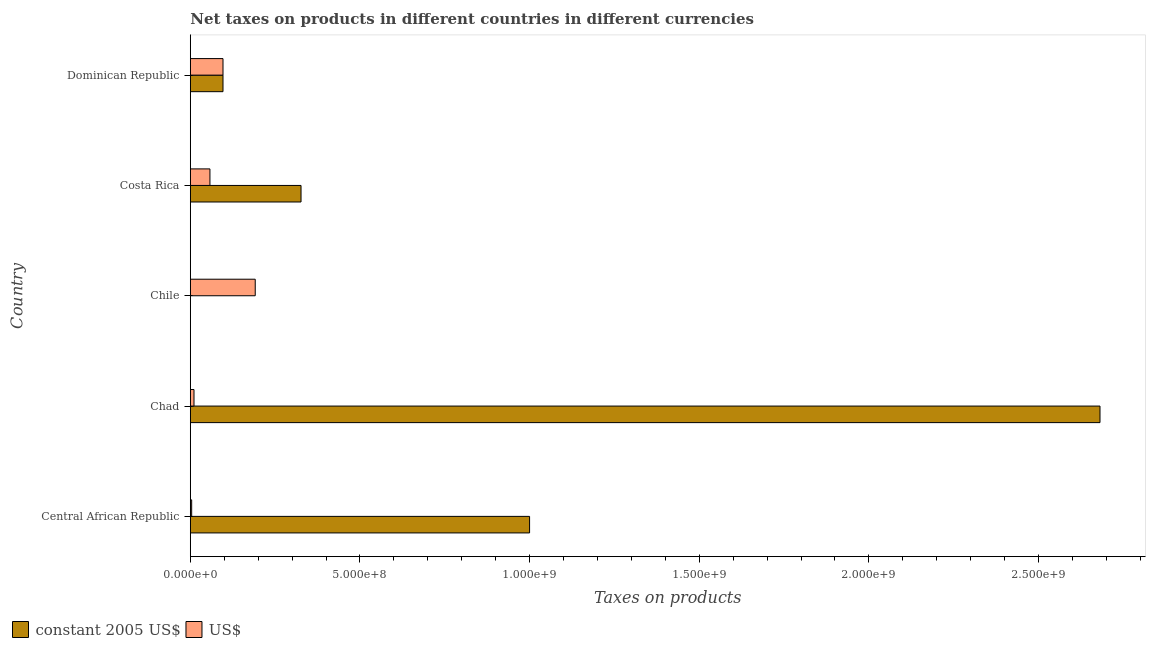How many different coloured bars are there?
Your answer should be compact. 2. Are the number of bars on each tick of the Y-axis equal?
Ensure brevity in your answer.  Yes. How many bars are there on the 3rd tick from the top?
Ensure brevity in your answer.  2. What is the label of the 5th group of bars from the top?
Provide a succinct answer. Central African Republic. What is the net taxes in constant 2005 us$ in Dominican Republic?
Your answer should be compact. 9.64e+07. Across all countries, what is the maximum net taxes in constant 2005 us$?
Keep it short and to the point. 2.68e+09. Across all countries, what is the minimum net taxes in constant 2005 us$?
Give a very brief answer. 2.02e+05. In which country was the net taxes in us$ minimum?
Provide a succinct answer. Central African Republic. What is the total net taxes in us$ in the graph?
Provide a short and direct response. 3.61e+08. What is the difference between the net taxes in constant 2005 us$ in Chad and that in Dominican Republic?
Your answer should be compact. 2.58e+09. What is the difference between the net taxes in constant 2005 us$ in Dominican Republic and the net taxes in us$ in Chad?
Provide a succinct answer. 8.55e+07. What is the average net taxes in constant 2005 us$ per country?
Your response must be concise. 8.21e+08. What is the difference between the net taxes in constant 2005 us$ and net taxes in us$ in Chile?
Ensure brevity in your answer.  -1.91e+08. In how many countries, is the net taxes in constant 2005 us$ greater than 1200000000 units?
Provide a succinct answer. 1. Is the net taxes in constant 2005 us$ in Costa Rica less than that in Dominican Republic?
Ensure brevity in your answer.  No. Is the difference between the net taxes in us$ in Chad and Chile greater than the difference between the net taxes in constant 2005 us$ in Chad and Chile?
Your response must be concise. No. What is the difference between the highest and the second highest net taxes in us$?
Keep it short and to the point. 9.50e+07. What is the difference between the highest and the lowest net taxes in us$?
Provide a short and direct response. 1.87e+08. Is the sum of the net taxes in constant 2005 us$ in Costa Rica and Dominican Republic greater than the maximum net taxes in us$ across all countries?
Provide a succinct answer. Yes. What does the 1st bar from the top in Chad represents?
Your answer should be compact. US$. What does the 1st bar from the bottom in Dominican Republic represents?
Offer a very short reply. Constant 2005 us$. How many bars are there?
Keep it short and to the point. 10. Are all the bars in the graph horizontal?
Provide a succinct answer. Yes. How many countries are there in the graph?
Give a very brief answer. 5. Does the graph contain any zero values?
Keep it short and to the point. No. What is the title of the graph?
Give a very brief answer. Net taxes on products in different countries in different currencies. Does "Sanitation services" appear as one of the legend labels in the graph?
Your answer should be very brief. No. What is the label or title of the X-axis?
Offer a terse response. Taxes on products. What is the Taxes on products in constant 2005 US$ in Central African Republic?
Provide a succinct answer. 1.00e+09. What is the Taxes on products in US$ in Central African Republic?
Make the answer very short. 4.08e+06. What is the Taxes on products of constant 2005 US$ in Chad?
Provide a succinct answer. 2.68e+09. What is the Taxes on products of US$ in Chad?
Ensure brevity in your answer.  1.09e+07. What is the Taxes on products in constant 2005 US$ in Chile?
Keep it short and to the point. 2.02e+05. What is the Taxes on products in US$ in Chile?
Your response must be concise. 1.91e+08. What is the Taxes on products of constant 2005 US$ in Costa Rica?
Keep it short and to the point. 3.26e+08. What is the Taxes on products in US$ in Costa Rica?
Your answer should be compact. 5.79e+07. What is the Taxes on products of constant 2005 US$ in Dominican Republic?
Keep it short and to the point. 9.64e+07. What is the Taxes on products in US$ in Dominican Republic?
Provide a short and direct response. 9.64e+07. Across all countries, what is the maximum Taxes on products in constant 2005 US$?
Make the answer very short. 2.68e+09. Across all countries, what is the maximum Taxes on products of US$?
Your answer should be very brief. 1.91e+08. Across all countries, what is the minimum Taxes on products in constant 2005 US$?
Provide a succinct answer. 2.02e+05. Across all countries, what is the minimum Taxes on products in US$?
Keep it short and to the point. 4.08e+06. What is the total Taxes on products of constant 2005 US$ in the graph?
Ensure brevity in your answer.  4.10e+09. What is the total Taxes on products in US$ in the graph?
Offer a very short reply. 3.61e+08. What is the difference between the Taxes on products in constant 2005 US$ in Central African Republic and that in Chad?
Offer a very short reply. -1.68e+09. What is the difference between the Taxes on products of US$ in Central African Republic and that in Chad?
Keep it short and to the point. -6.86e+06. What is the difference between the Taxes on products of constant 2005 US$ in Central African Republic and that in Chile?
Your answer should be compact. 1.00e+09. What is the difference between the Taxes on products in US$ in Central African Republic and that in Chile?
Ensure brevity in your answer.  -1.87e+08. What is the difference between the Taxes on products of constant 2005 US$ in Central African Republic and that in Costa Rica?
Your answer should be compact. 6.74e+08. What is the difference between the Taxes on products of US$ in Central African Republic and that in Costa Rica?
Make the answer very short. -5.38e+07. What is the difference between the Taxes on products of constant 2005 US$ in Central African Republic and that in Dominican Republic?
Make the answer very short. 9.04e+08. What is the difference between the Taxes on products in US$ in Central African Republic and that in Dominican Republic?
Provide a succinct answer. -9.23e+07. What is the difference between the Taxes on products of constant 2005 US$ in Chad and that in Chile?
Provide a succinct answer. 2.68e+09. What is the difference between the Taxes on products in US$ in Chad and that in Chile?
Make the answer very short. -1.80e+08. What is the difference between the Taxes on products in constant 2005 US$ in Chad and that in Costa Rica?
Provide a short and direct response. 2.35e+09. What is the difference between the Taxes on products in US$ in Chad and that in Costa Rica?
Provide a succinct answer. -4.70e+07. What is the difference between the Taxes on products in constant 2005 US$ in Chad and that in Dominican Republic?
Your response must be concise. 2.58e+09. What is the difference between the Taxes on products of US$ in Chad and that in Dominican Republic?
Provide a short and direct response. -8.55e+07. What is the difference between the Taxes on products of constant 2005 US$ in Chile and that in Costa Rica?
Provide a succinct answer. -3.26e+08. What is the difference between the Taxes on products of US$ in Chile and that in Costa Rica?
Provide a short and direct response. 1.33e+08. What is the difference between the Taxes on products of constant 2005 US$ in Chile and that in Dominican Republic?
Offer a terse response. -9.62e+07. What is the difference between the Taxes on products in US$ in Chile and that in Dominican Republic?
Your answer should be compact. 9.50e+07. What is the difference between the Taxes on products in constant 2005 US$ in Costa Rica and that in Dominican Republic?
Your answer should be very brief. 2.30e+08. What is the difference between the Taxes on products of US$ in Costa Rica and that in Dominican Republic?
Give a very brief answer. -3.85e+07. What is the difference between the Taxes on products of constant 2005 US$ in Central African Republic and the Taxes on products of US$ in Chad?
Provide a short and direct response. 9.89e+08. What is the difference between the Taxes on products in constant 2005 US$ in Central African Republic and the Taxes on products in US$ in Chile?
Ensure brevity in your answer.  8.09e+08. What is the difference between the Taxes on products of constant 2005 US$ in Central African Republic and the Taxes on products of US$ in Costa Rica?
Give a very brief answer. 9.42e+08. What is the difference between the Taxes on products in constant 2005 US$ in Central African Republic and the Taxes on products in US$ in Dominican Republic?
Give a very brief answer. 9.04e+08. What is the difference between the Taxes on products of constant 2005 US$ in Chad and the Taxes on products of US$ in Chile?
Ensure brevity in your answer.  2.49e+09. What is the difference between the Taxes on products in constant 2005 US$ in Chad and the Taxes on products in US$ in Costa Rica?
Provide a short and direct response. 2.62e+09. What is the difference between the Taxes on products in constant 2005 US$ in Chad and the Taxes on products in US$ in Dominican Republic?
Provide a short and direct response. 2.58e+09. What is the difference between the Taxes on products of constant 2005 US$ in Chile and the Taxes on products of US$ in Costa Rica?
Provide a succinct answer. -5.77e+07. What is the difference between the Taxes on products in constant 2005 US$ in Chile and the Taxes on products in US$ in Dominican Republic?
Your answer should be compact. -9.62e+07. What is the difference between the Taxes on products in constant 2005 US$ in Costa Rica and the Taxes on products in US$ in Dominican Republic?
Your answer should be very brief. 2.30e+08. What is the average Taxes on products in constant 2005 US$ per country?
Keep it short and to the point. 8.21e+08. What is the average Taxes on products in US$ per country?
Your response must be concise. 7.21e+07. What is the difference between the Taxes on products in constant 2005 US$ and Taxes on products in US$ in Central African Republic?
Make the answer very short. 9.96e+08. What is the difference between the Taxes on products of constant 2005 US$ and Taxes on products of US$ in Chad?
Make the answer very short. 2.67e+09. What is the difference between the Taxes on products in constant 2005 US$ and Taxes on products in US$ in Chile?
Offer a very short reply. -1.91e+08. What is the difference between the Taxes on products in constant 2005 US$ and Taxes on products in US$ in Costa Rica?
Your answer should be compact. 2.68e+08. What is the difference between the Taxes on products in constant 2005 US$ and Taxes on products in US$ in Dominican Republic?
Keep it short and to the point. 0. What is the ratio of the Taxes on products of constant 2005 US$ in Central African Republic to that in Chad?
Offer a very short reply. 0.37. What is the ratio of the Taxes on products of US$ in Central African Republic to that in Chad?
Your answer should be compact. 0.37. What is the ratio of the Taxes on products in constant 2005 US$ in Central African Republic to that in Chile?
Make the answer very short. 4938.27. What is the ratio of the Taxes on products of US$ in Central African Republic to that in Chile?
Your answer should be very brief. 0.02. What is the ratio of the Taxes on products of constant 2005 US$ in Central African Republic to that in Costa Rica?
Ensure brevity in your answer.  3.06. What is the ratio of the Taxes on products of US$ in Central African Republic to that in Costa Rica?
Provide a short and direct response. 0.07. What is the ratio of the Taxes on products in constant 2005 US$ in Central African Republic to that in Dominican Republic?
Provide a succinct answer. 10.37. What is the ratio of the Taxes on products of US$ in Central African Republic to that in Dominican Republic?
Your answer should be compact. 0.04. What is the ratio of the Taxes on products of constant 2005 US$ in Chad to that in Chile?
Offer a very short reply. 1.32e+04. What is the ratio of the Taxes on products in US$ in Chad to that in Chile?
Offer a terse response. 0.06. What is the ratio of the Taxes on products of constant 2005 US$ in Chad to that in Costa Rica?
Your response must be concise. 8.21. What is the ratio of the Taxes on products in US$ in Chad to that in Costa Rica?
Offer a very short reply. 0.19. What is the ratio of the Taxes on products of constant 2005 US$ in Chad to that in Dominican Republic?
Ensure brevity in your answer.  27.81. What is the ratio of the Taxes on products in US$ in Chad to that in Dominican Republic?
Ensure brevity in your answer.  0.11. What is the ratio of the Taxes on products of constant 2005 US$ in Chile to that in Costa Rica?
Ensure brevity in your answer.  0. What is the ratio of the Taxes on products of US$ in Chile to that in Costa Rica?
Offer a very short reply. 3.31. What is the ratio of the Taxes on products of constant 2005 US$ in Chile to that in Dominican Republic?
Your answer should be very brief. 0. What is the ratio of the Taxes on products in US$ in Chile to that in Dominican Republic?
Keep it short and to the point. 1.99. What is the ratio of the Taxes on products of constant 2005 US$ in Costa Rica to that in Dominican Republic?
Your response must be concise. 3.39. What is the ratio of the Taxes on products of US$ in Costa Rica to that in Dominican Republic?
Provide a succinct answer. 0.6. What is the difference between the highest and the second highest Taxes on products of constant 2005 US$?
Offer a very short reply. 1.68e+09. What is the difference between the highest and the second highest Taxes on products of US$?
Your answer should be compact. 9.50e+07. What is the difference between the highest and the lowest Taxes on products of constant 2005 US$?
Offer a very short reply. 2.68e+09. What is the difference between the highest and the lowest Taxes on products of US$?
Your answer should be compact. 1.87e+08. 